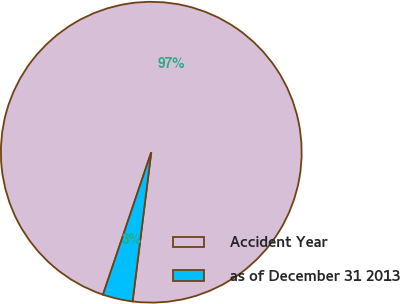<chart> <loc_0><loc_0><loc_500><loc_500><pie_chart><fcel>Accident Year<fcel>as of December 31 2013<nl><fcel>96.78%<fcel>3.22%<nl></chart> 